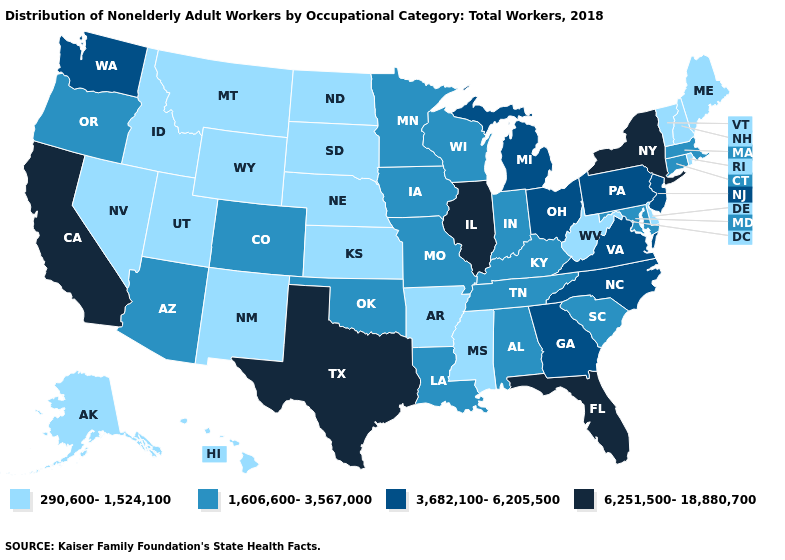What is the value of Florida?
Give a very brief answer. 6,251,500-18,880,700. Which states have the lowest value in the Northeast?
Quick response, please. Maine, New Hampshire, Rhode Island, Vermont. What is the lowest value in the USA?
Answer briefly. 290,600-1,524,100. Does Utah have the lowest value in the USA?
Short answer required. Yes. What is the lowest value in the USA?
Short answer required. 290,600-1,524,100. Among the states that border Louisiana , which have the lowest value?
Quick response, please. Arkansas, Mississippi. What is the value of New Mexico?
Give a very brief answer. 290,600-1,524,100. What is the value of Minnesota?
Give a very brief answer. 1,606,600-3,567,000. Name the states that have a value in the range 290,600-1,524,100?
Be succinct. Alaska, Arkansas, Delaware, Hawaii, Idaho, Kansas, Maine, Mississippi, Montana, Nebraska, Nevada, New Hampshire, New Mexico, North Dakota, Rhode Island, South Dakota, Utah, Vermont, West Virginia, Wyoming. Which states hav the highest value in the West?
Write a very short answer. California. Is the legend a continuous bar?
Be succinct. No. What is the highest value in the Northeast ?
Be succinct. 6,251,500-18,880,700. What is the value of Tennessee?
Be succinct. 1,606,600-3,567,000. Name the states that have a value in the range 6,251,500-18,880,700?
Answer briefly. California, Florida, Illinois, New York, Texas. 